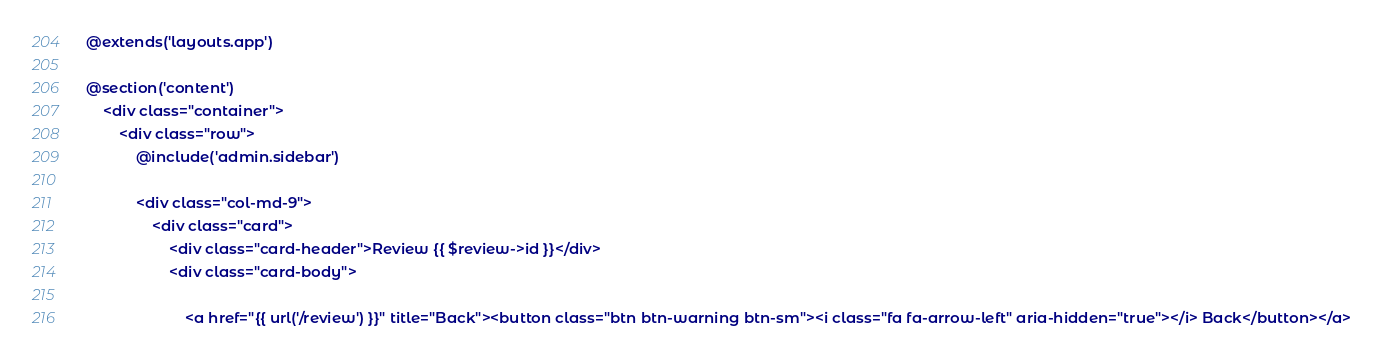Convert code to text. <code><loc_0><loc_0><loc_500><loc_500><_PHP_>@extends('layouts.app')

@section('content')
    <div class="container">
        <div class="row">
            @include('admin.sidebar')

            <div class="col-md-9">
                <div class="card">
                    <div class="card-header">Review {{ $review->id }}</div>
                    <div class="card-body">

                        <a href="{{ url('/review') }}" title="Back"><button class="btn btn-warning btn-sm"><i class="fa fa-arrow-left" aria-hidden="true"></i> Back</button></a></code> 